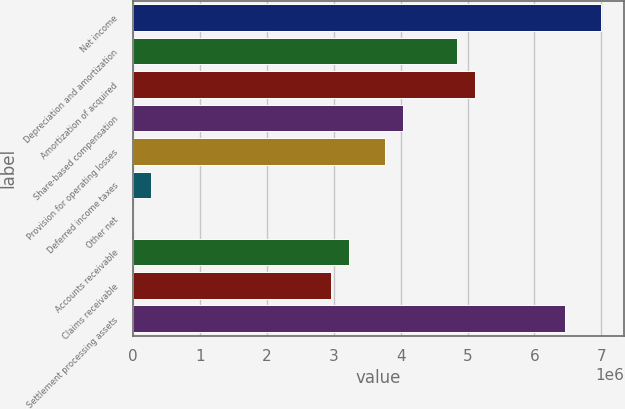<chart> <loc_0><loc_0><loc_500><loc_500><bar_chart><fcel>Net income<fcel>Depreciation and amortization<fcel>Amortization of acquired<fcel>Share-based compensation<fcel>Provision for operating losses<fcel>Deferred income taxes<fcel>Other net<fcel>Accounts receivable<fcel>Claims receivable<fcel>Settlement processing assets<nl><fcel>6.99163e+06<fcel>4.84081e+06<fcel>5.10966e+06<fcel>4.03426e+06<fcel>3.76541e+06<fcel>270336<fcel>1484<fcel>3.2277e+06<fcel>2.95885e+06<fcel>6.45392e+06<nl></chart> 